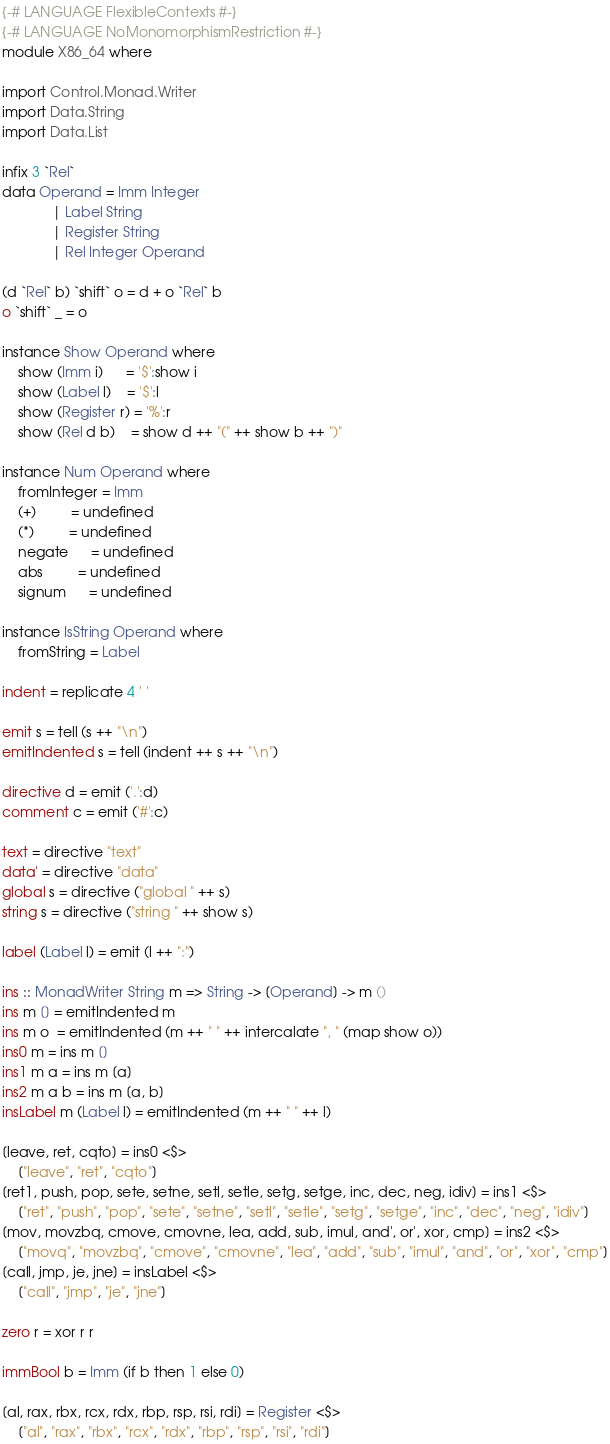<code> <loc_0><loc_0><loc_500><loc_500><_Haskell_>{-# LANGUAGE FlexibleContexts #-}
{-# LANGUAGE NoMonomorphismRestriction #-}
module X86_64 where

import Control.Monad.Writer
import Data.String
import Data.List

infix 3 `Rel`
data Operand = Imm Integer
             | Label String
             | Register String
             | Rel Integer Operand

(d `Rel` b) `shift` o = d + o `Rel` b
o `shift` _ = o

instance Show Operand where
    show (Imm i)      = '$':show i
    show (Label l)    = '$':l
    show (Register r) = '%':r
    show (Rel d b)    = show d ++ "(" ++ show b ++ ")"

instance Num Operand where
    fromInteger = Imm
    (+)         = undefined
    (*)         = undefined
    negate      = undefined
    abs         = undefined
    signum      = undefined

instance IsString Operand where
    fromString = Label

indent = replicate 4 ' '

emit s = tell (s ++ "\n")
emitIndented s = tell (indent ++ s ++ "\n")

directive d = emit ('.':d)
comment c = emit ('#':c)

text = directive "text"
data' = directive "data"
global s = directive ("global " ++ s)
string s = directive ("string " ++ show s)

label (Label l) = emit (l ++ ":")

ins :: MonadWriter String m => String -> [Operand] -> m ()
ins m [] = emitIndented m
ins m o  = emitIndented (m ++ " " ++ intercalate ", " (map show o))
ins0 m = ins m []
ins1 m a = ins m [a]
ins2 m a b = ins m [a, b]
insLabel m (Label l) = emitIndented (m ++ " " ++ l)

[leave, ret, cqto] = ins0 <$>
    ["leave", "ret", "cqto"]
[ret1, push, pop, sete, setne, setl, setle, setg, setge, inc, dec, neg, idiv] = ins1 <$>
    ["ret", "push", "pop", "sete", "setne", "setl", "setle", "setg", "setge", "inc", "dec", "neg", "idiv"]
[mov, movzbq, cmove, cmovne, lea, add, sub, imul, and', or', xor, cmp] = ins2 <$>
    ["movq", "movzbq", "cmove", "cmovne", "lea", "add", "sub", "imul", "and", "or", "xor", "cmp"]
[call, jmp, je, jne] = insLabel <$>
    ["call", "jmp", "je", "jne"]

zero r = xor r r

immBool b = Imm (if b then 1 else 0)

[al, rax, rbx, rcx, rdx, rbp, rsp, rsi, rdi] = Register <$>
    ["al", "rax", "rbx", "rcx", "rdx", "rbp", "rsp", "rsi", "rdi"]
</code> 